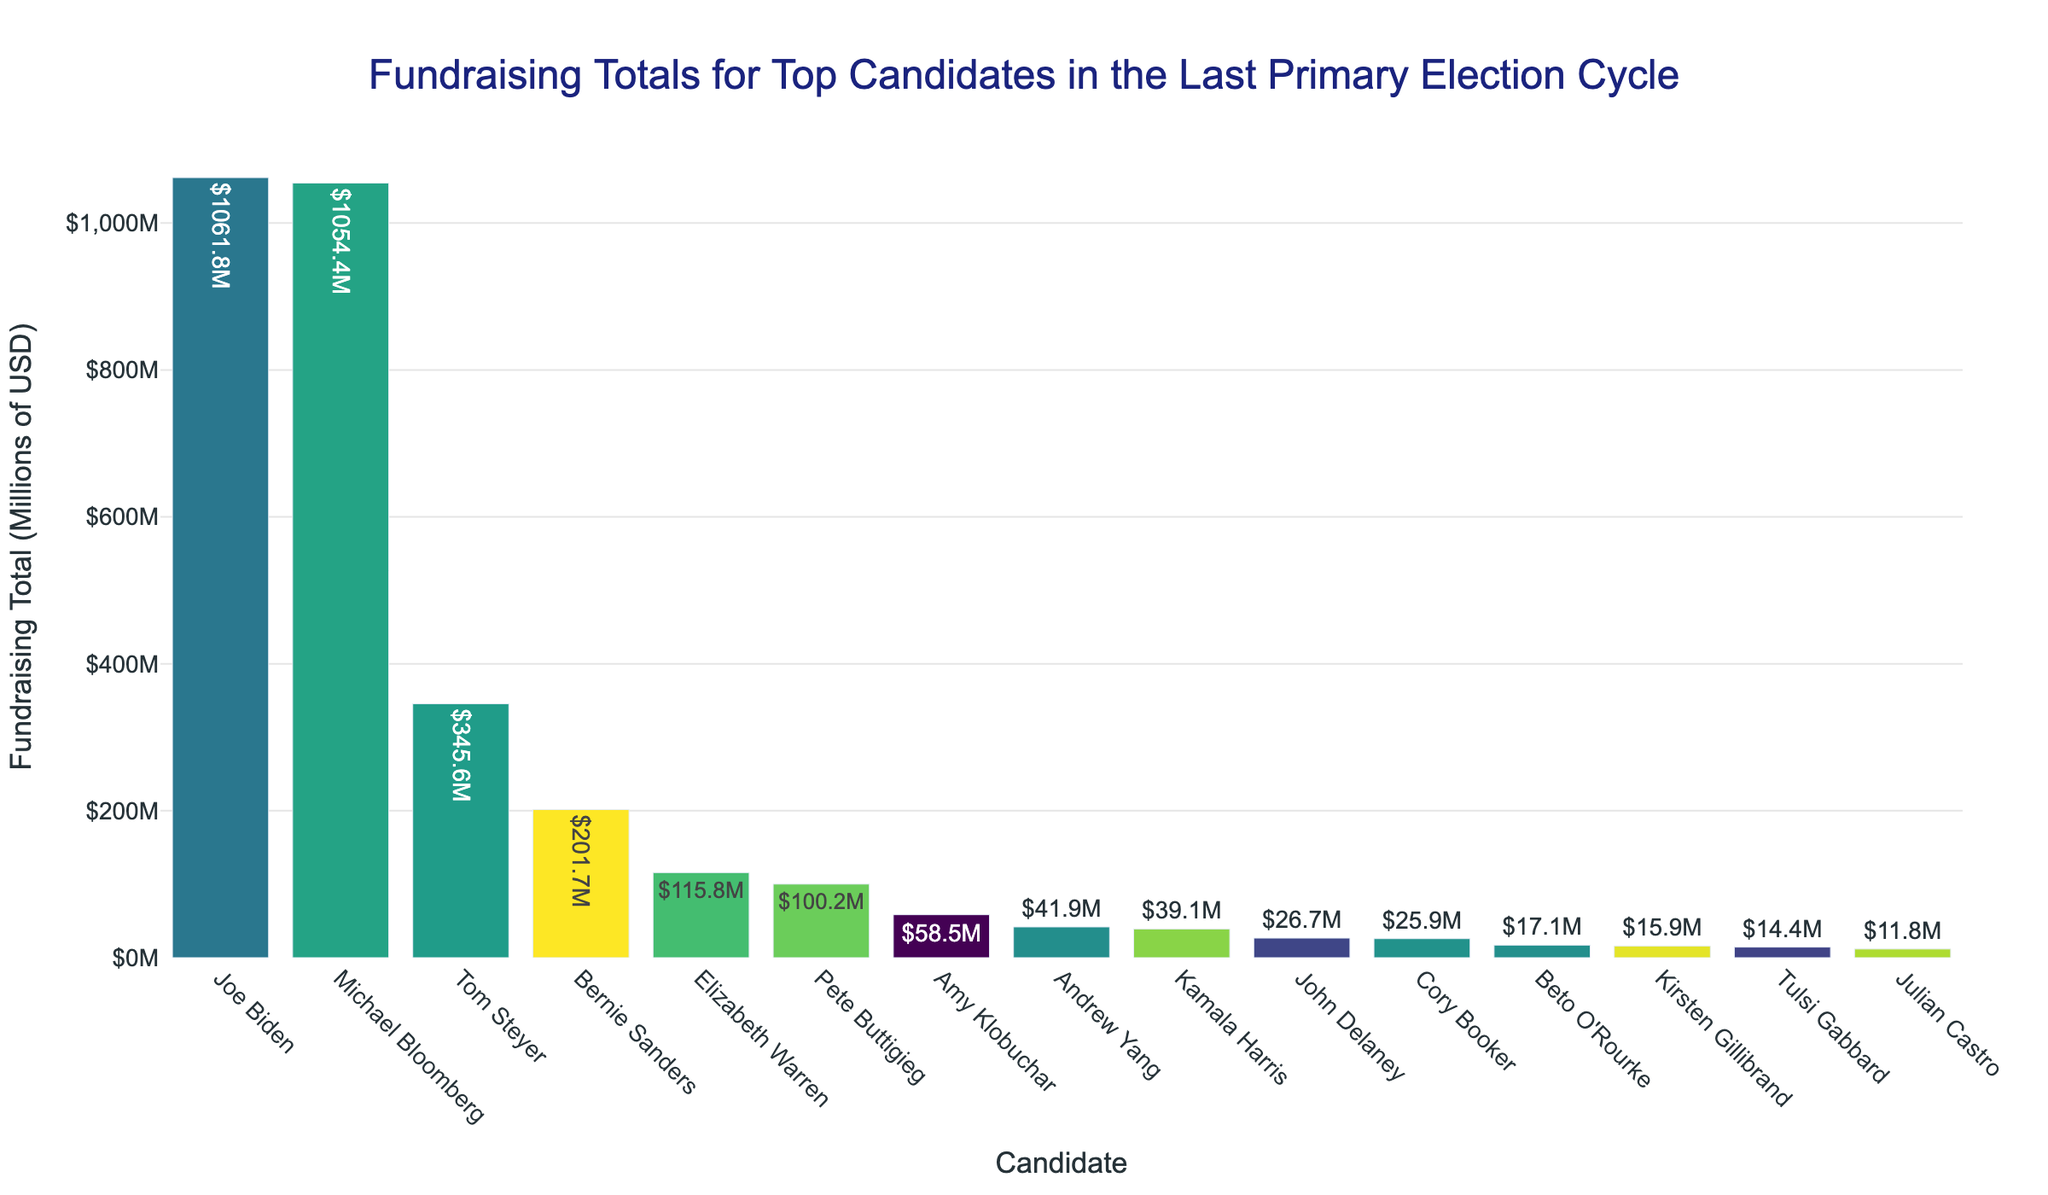Who raised the most funds? To find who raised the most funds, look for the bar that reaches the highest value on the y-axis. In this case, Joe Biden's bar is the tallest, indicating he raised the most.
Answer: Joe Biden Who raised the least funds? To identify who raised the least funds, look for the shortest bar in the chart. The shortest bar belongs to Julian Castro.
Answer: Julian Castro What is the total amount raised by Joe Biden and Michael Bloomberg combined? First, note the amounts raised by Joe Biden ($1061.8M) and Michael Bloomberg ($1054.4M). Then, sum them: 1061.8 + 1054.4 = 2116.2.
Answer: $2116.2M Who raised more funds: Elizabeth Warren or Pete Buttigieg? Compare the heights of the bars for Elizabeth Warren and Pete Buttigieg. Elizabeth Warren's bar is slightly higher as she raised $115.8M compared to Pete Buttigieg's $100.2M.
Answer: Elizabeth Warren What is the average fundraising total of the top 5 candidates? First identify the top 5 candidates: Joe Biden ($1061.8M), Michael Bloomberg ($1054.4M), Bernie Sanders ($201.7M), Tom Steyer ($345.6M), and Elizabeth Warren ($115.8M). Then, sum their totals: 1061.8 + 1054.4 + 201.7 + 345.6 + 115.8 = 2779.3. Finally, divide by 5: 2779.3 / 5 = 555.86.
Answer: $555.9M Which candidates raised more than $100 million? Inspect the bars and identify the ones that exceed $100M on the y-axis. The candidates are Joe Biden, Michael Bloomberg, Bernie Sanders, Elizabeth Warren, and Pete Buttigieg.
Answer: Joe Biden, Michael Bloomberg, Bernie Sanders, Elizabeth Warren, Pete Buttigieg How much more did Joe Biden raise than Bernie Sanders? Subtract Bernie Sanders's fundraising total from Joe Biden's: 1061.8 - 201.7 = 860.1.
Answer: $860.1M What is the difference in fundraising totals between the candidate with the highest and the candidate with the lowest amounts raised? Subtract the lowest amount (Julian Castro: $11.8M) from the highest amount (Joe Biden: $1061.8M): 1061.8 - 11.8 = 1050.
Answer: $1050M Who are the third and fourth highest fundraisers, and what are their totals? Rank the candidates and find the third and fourth: Bernie Sanders (3rd: $201.7M) and Tom Steyer (4th: $345.6M).
Answer: Bernie Sanders: $201.7M, Tom Steyer: $345.6M How many candidates raised between $10M and $50M? Count the bars that fall between the $10M and $50M range on the y-axis. The candidates are Andrew Yang ($41.9M), Kamala Harris ($39.1M), John Delaney ($26.7M), Cory Booker ($25.9M), Kirsten Gillibrand ($15.9M), Beto O'Rourke ($17.1M), and Tulsi Gabbard ($14.4M).
Answer: 7 